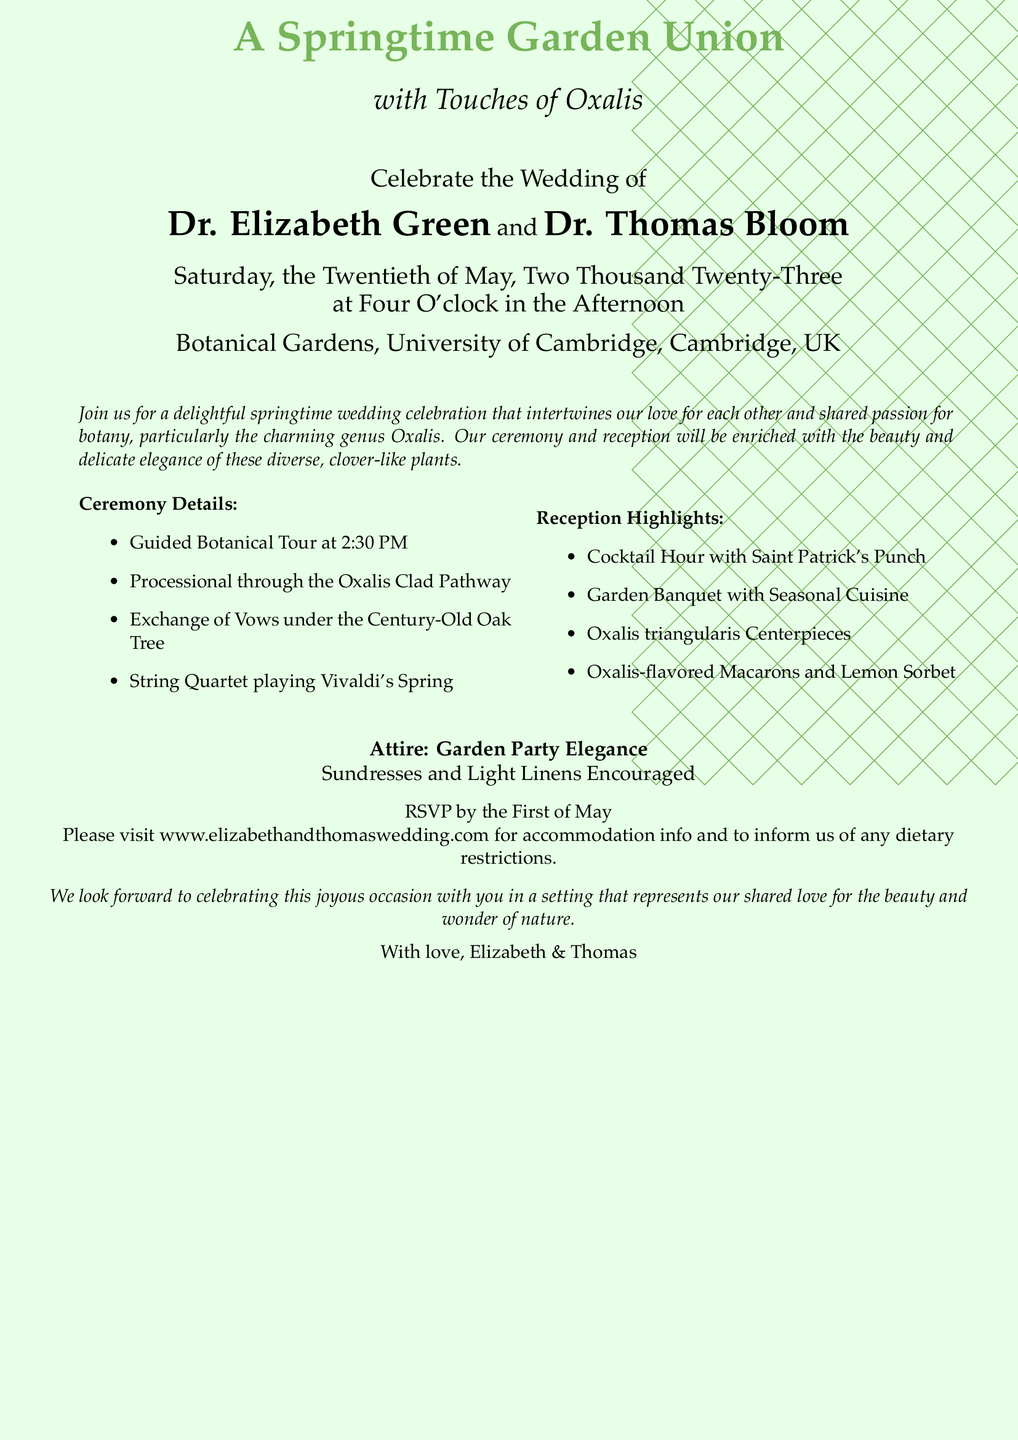What is the date of the wedding? The wedding is scheduled for Saturday, the Twentieth of May, Two Thousand Twenty-Three.
Answer: May Twentieth, Two Thousand Twenty-Three Who are the couple getting married? The names of the couple getting married are mentioned in the document as Dr. Elizabeth Green and Dr. Thomas Bloom.
Answer: Dr. Elizabeth Green and Dr. Thomas Bloom Where is the wedding ceremony taking place? The location of the wedding ceremony is specified as Botanical Gardens, University of Cambridge, Cambridge, UK.
Answer: Botanical Gardens, University of Cambridge, Cambridge, UK What type of centerpieces will be used? The document states that Oxalis triangularis Centerpieces will be used at the reception.
Answer: Oxalis triangularis Centerpieces What is the attire suggested for the wedding? The attire suggested in the invitation is described as "Garden Party Elegance."
Answer: Garden Party Elegance What time does the ceremony start? The ceremony is set to start at Four O'clock in the Afternoon.
Answer: Four O'clock in the Afternoon What will the String Quartet play during the ceremony? The music to be played by the String Quartet during the ceremony is Vivaldi's Spring.
Answer: Vivaldi's Spring What cocktail will be served during the reception? The document mentions that Saint Patrick's Punch will be served during the cocktail hour.
Answer: Saint Patrick's Punch 